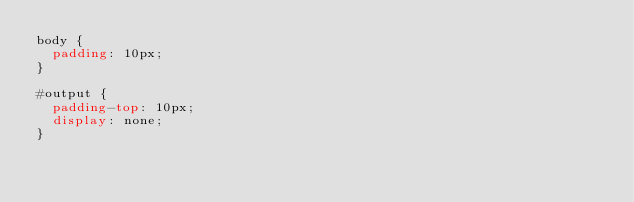Convert code to text. <code><loc_0><loc_0><loc_500><loc_500><_CSS_>body {
  padding: 10px;
}

#output {
  padding-top: 10px;
  display: none;
}
</code> 